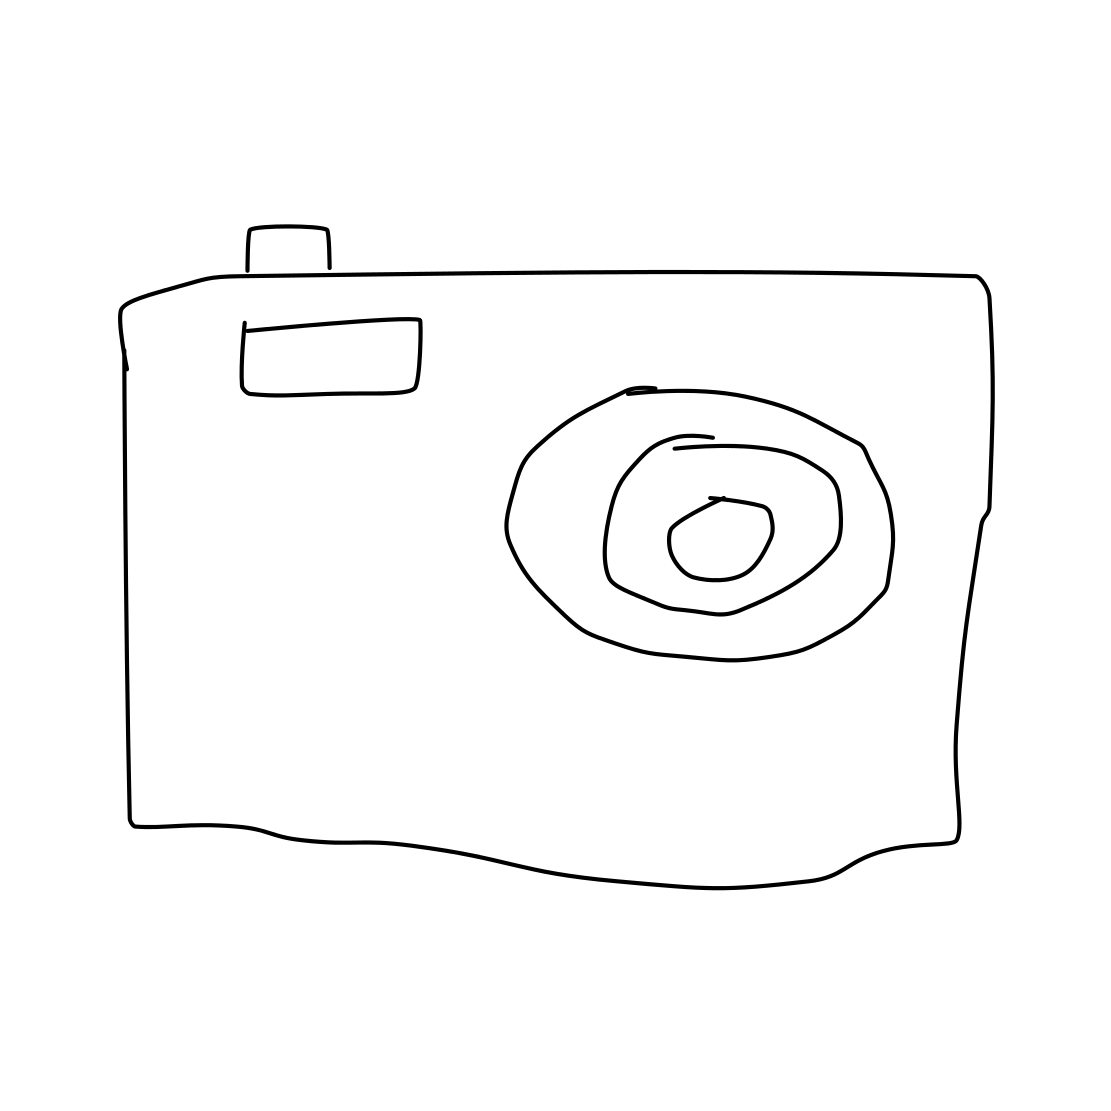What might this camera be used for? Given that it is a drawing of a camera, in a real-world context, such a device would typically be used to capture photographs or videos. The camera is a tool for preserving moments, creating art, or documenting information visually. 